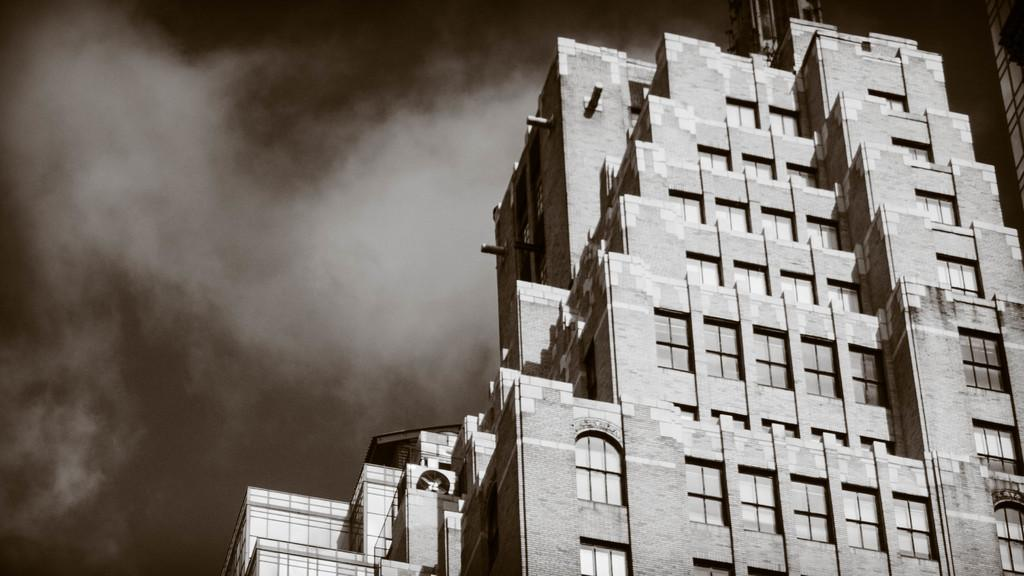What is the color scheme of the image? The image is black and white. What is the main subject of the image? There is a picture of a building in the image. What else can be seen in the image besides the building? The sky is visible in the image. Can you describe the sky in the image? Clouds are present in the sky. How many beggars can be seen in the image? There are no beggars present in the image. What type of spot is visible on the building in the image? There is no spot visible on the building in the image. 